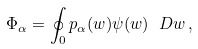Convert formula to latex. <formula><loc_0><loc_0><loc_500><loc_500>\Phi _ { \alpha } = \oint _ { 0 } p _ { \alpha } ( w ) \psi ( w ) \ D { w } \, ,</formula> 